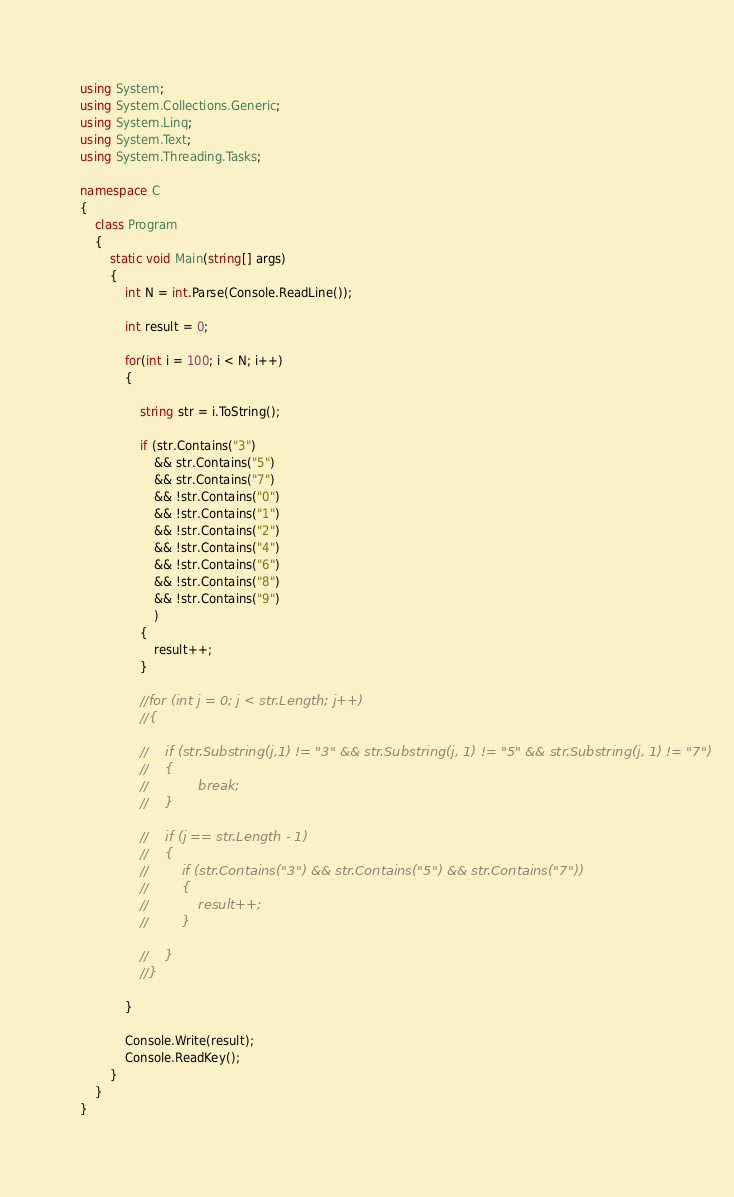Convert code to text. <code><loc_0><loc_0><loc_500><loc_500><_C#_>using System;
using System.Collections.Generic;
using System.Linq;
using System.Text;
using System.Threading.Tasks;

namespace C
{
    class Program
    {
        static void Main(string[] args)
        {
            int N = int.Parse(Console.ReadLine());

            int result = 0;

            for(int i = 100; i < N; i++)
            {

                string str = i.ToString();

                if (str.Contains("3")
                    && str.Contains("5")
                    && str.Contains("7")
                    && !str.Contains("0")
                    && !str.Contains("1")
                    && !str.Contains("2")
                    && !str.Contains("4")
                    && !str.Contains("6")
                    && !str.Contains("8")
                    && !str.Contains("9")
                    )
                {
                    result++;
                }

                //for (int j = 0; j < str.Length; j++)
                //{

                //    if (str.Substring(j,1) != "3" && str.Substring(j, 1) != "5" && str.Substring(j, 1) != "7")
                //    {
                //            break;
                //    }

                //    if (j == str.Length - 1)
                //    {
                //        if (str.Contains("3") && str.Contains("5") && str.Contains("7"))
                //        {
                //            result++;
                //        }

                //    }
                //}

            }

            Console.Write(result);
            Console.ReadKey();
        }
    }
}</code> 